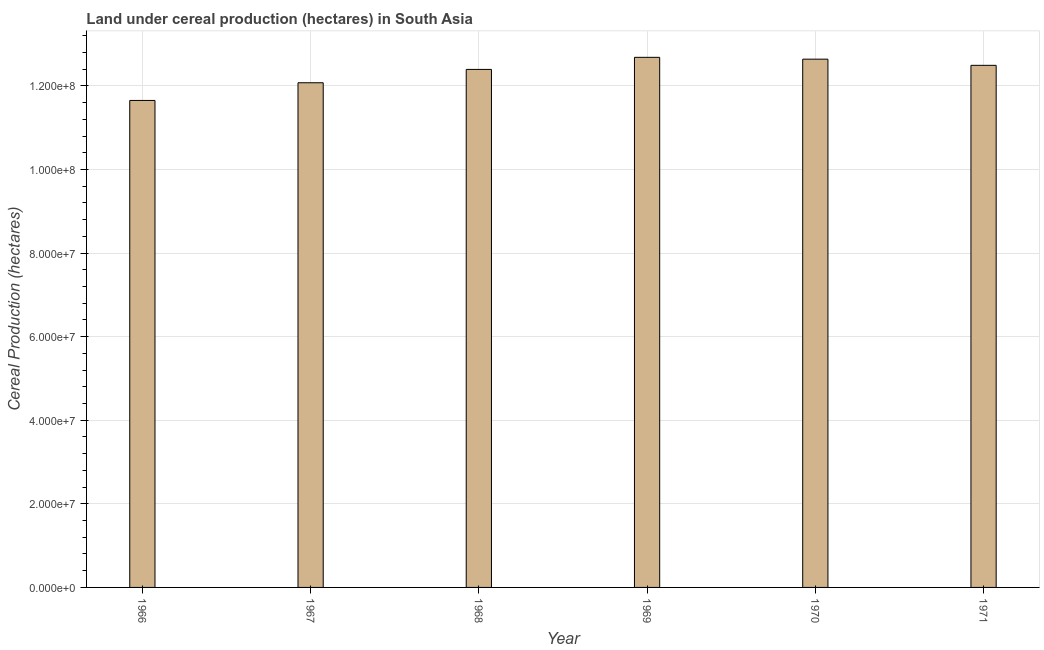Does the graph contain any zero values?
Ensure brevity in your answer.  No. What is the title of the graph?
Keep it short and to the point. Land under cereal production (hectares) in South Asia. What is the label or title of the Y-axis?
Your answer should be compact. Cereal Production (hectares). What is the land under cereal production in 1969?
Make the answer very short. 1.27e+08. Across all years, what is the maximum land under cereal production?
Provide a short and direct response. 1.27e+08. Across all years, what is the minimum land under cereal production?
Provide a short and direct response. 1.17e+08. In which year was the land under cereal production maximum?
Keep it short and to the point. 1969. In which year was the land under cereal production minimum?
Give a very brief answer. 1966. What is the sum of the land under cereal production?
Offer a terse response. 7.39e+08. What is the difference between the land under cereal production in 1966 and 1967?
Your answer should be very brief. -4.23e+06. What is the average land under cereal production per year?
Make the answer very short. 1.23e+08. What is the median land under cereal production?
Offer a terse response. 1.24e+08. What is the ratio of the land under cereal production in 1966 to that in 1971?
Make the answer very short. 0.93. What is the difference between the highest and the second highest land under cereal production?
Your answer should be very brief. 4.40e+05. What is the difference between the highest and the lowest land under cereal production?
Your response must be concise. 1.03e+07. Are all the bars in the graph horizontal?
Keep it short and to the point. No. How many years are there in the graph?
Offer a terse response. 6. What is the Cereal Production (hectares) of 1966?
Offer a terse response. 1.17e+08. What is the Cereal Production (hectares) in 1967?
Provide a succinct answer. 1.21e+08. What is the Cereal Production (hectares) of 1968?
Provide a short and direct response. 1.24e+08. What is the Cereal Production (hectares) of 1969?
Ensure brevity in your answer.  1.27e+08. What is the Cereal Production (hectares) of 1970?
Make the answer very short. 1.26e+08. What is the Cereal Production (hectares) of 1971?
Offer a terse response. 1.25e+08. What is the difference between the Cereal Production (hectares) in 1966 and 1967?
Provide a succinct answer. -4.23e+06. What is the difference between the Cereal Production (hectares) in 1966 and 1968?
Your answer should be compact. -7.42e+06. What is the difference between the Cereal Production (hectares) in 1966 and 1969?
Provide a succinct answer. -1.03e+07. What is the difference between the Cereal Production (hectares) in 1966 and 1970?
Your answer should be compact. -9.87e+06. What is the difference between the Cereal Production (hectares) in 1966 and 1971?
Keep it short and to the point. -8.40e+06. What is the difference between the Cereal Production (hectares) in 1967 and 1968?
Your answer should be very brief. -3.19e+06. What is the difference between the Cereal Production (hectares) in 1967 and 1969?
Your response must be concise. -6.08e+06. What is the difference between the Cereal Production (hectares) in 1967 and 1970?
Your answer should be compact. -5.64e+06. What is the difference between the Cereal Production (hectares) in 1967 and 1971?
Give a very brief answer. -4.17e+06. What is the difference between the Cereal Production (hectares) in 1968 and 1969?
Provide a short and direct response. -2.89e+06. What is the difference between the Cereal Production (hectares) in 1968 and 1970?
Provide a short and direct response. -2.45e+06. What is the difference between the Cereal Production (hectares) in 1968 and 1971?
Keep it short and to the point. -9.78e+05. What is the difference between the Cereal Production (hectares) in 1969 and 1970?
Your answer should be compact. 4.40e+05. What is the difference between the Cereal Production (hectares) in 1969 and 1971?
Provide a succinct answer. 1.91e+06. What is the difference between the Cereal Production (hectares) in 1970 and 1971?
Your response must be concise. 1.47e+06. What is the ratio of the Cereal Production (hectares) in 1966 to that in 1967?
Your response must be concise. 0.96. What is the ratio of the Cereal Production (hectares) in 1966 to that in 1969?
Provide a succinct answer. 0.92. What is the ratio of the Cereal Production (hectares) in 1966 to that in 1970?
Keep it short and to the point. 0.92. What is the ratio of the Cereal Production (hectares) in 1966 to that in 1971?
Your answer should be very brief. 0.93. What is the ratio of the Cereal Production (hectares) in 1967 to that in 1970?
Ensure brevity in your answer.  0.95. What is the ratio of the Cereal Production (hectares) in 1967 to that in 1971?
Provide a short and direct response. 0.97. What is the ratio of the Cereal Production (hectares) in 1968 to that in 1969?
Provide a succinct answer. 0.98. What is the ratio of the Cereal Production (hectares) in 1969 to that in 1971?
Offer a terse response. 1.01. What is the ratio of the Cereal Production (hectares) in 1970 to that in 1971?
Provide a short and direct response. 1.01. 